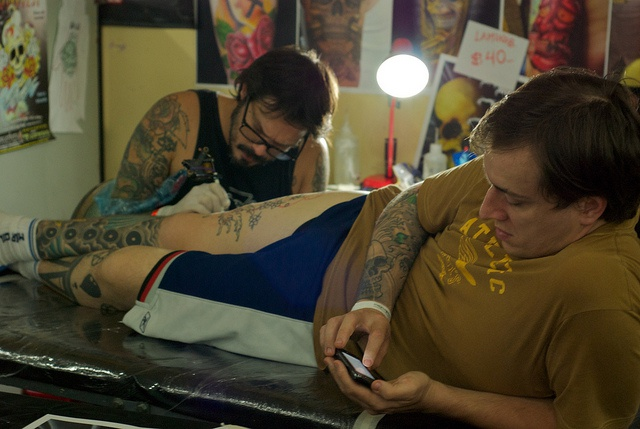Describe the objects in this image and their specific colors. I can see people in darkgreen, black, olive, maroon, and gray tones, bed in darkgreen, black, and gray tones, people in darkgreen, black, olive, and gray tones, and cell phone in darkgreen, black, darkgray, gray, and maroon tones in this image. 